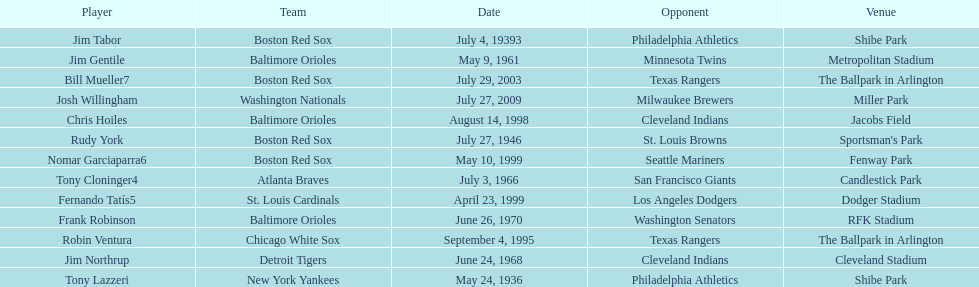Which teams faced off at miller park? Washington Nationals, Milwaukee Brewers. 